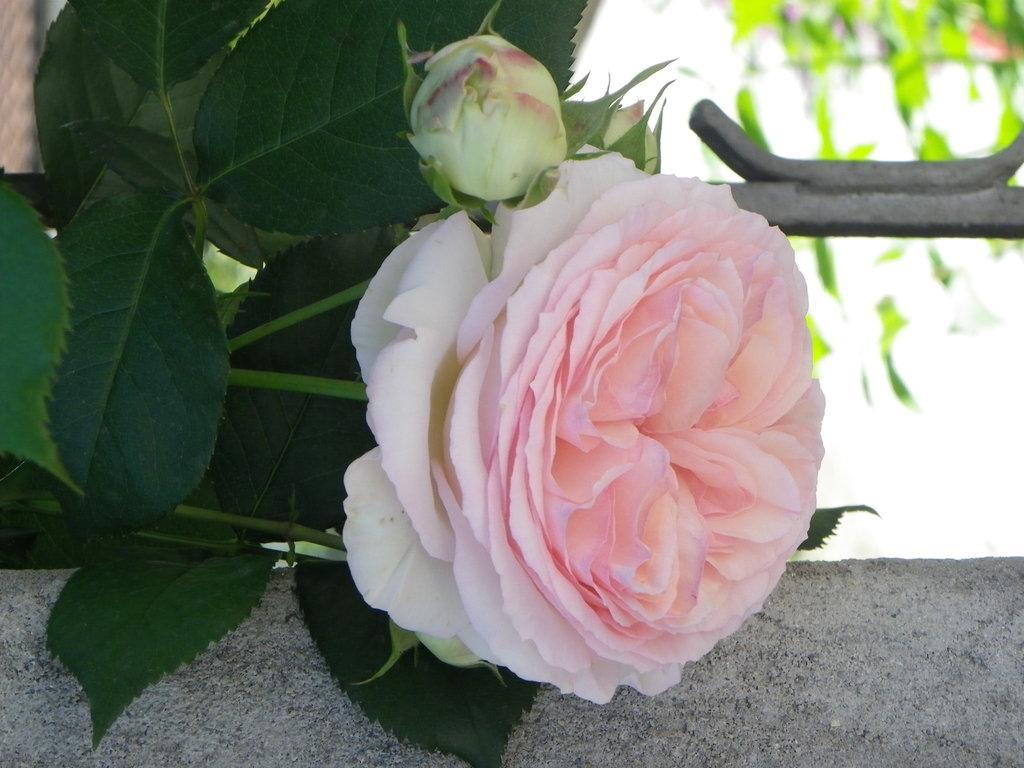Could you give a brief overview of what you see in this image? In this picture there is a flower in the center of the image. 